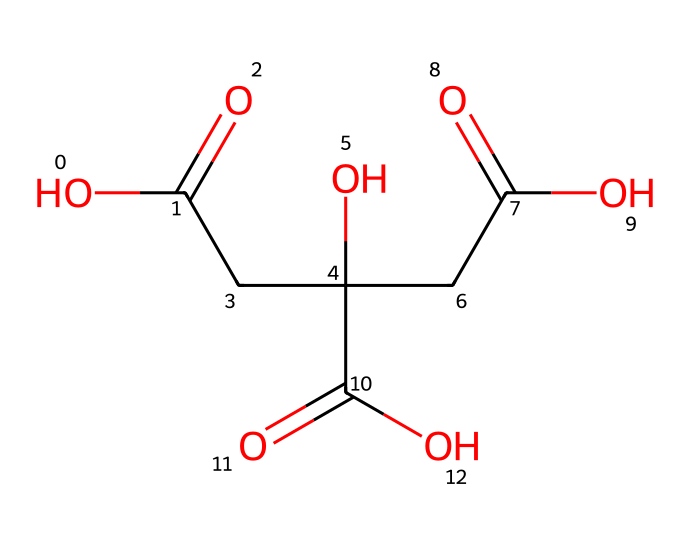What is the name of this acid? The molecular structure is indicative of citric acid, which is commonly found in citrus fruits like lemons.
Answer: citric acid How many carboxylic acid groups are present in citric acid? By analyzing the structure, we can see three distinct carboxylic acid groups (-COOH) indicated by the carbonyl oxygen bonded to a hydroxyl group.
Answer: three What is the molecular formula of citric acid? By counting the atoms in the SMILES representation, we can deduce that citric acid has six carbons, eight hydrogens, and seven oxygens, which corresponds to its molecular formula C6H8O7.
Answer: C6H8O7 How many stereocenters are present in citric acid? The structure contains asymmetric carbon atoms which are bound to four different groups; in this case, there are three stereocenters in citric acid.
Answer: three Does citric acid possess any hydroxyl groups? The SMILES representation includes -OH groups, represented by the "O" following the carbon atoms, confirming the presence of hydroxyl functional groups.
Answer: yes 